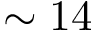<formula> <loc_0><loc_0><loc_500><loc_500>\sim 1 4</formula> 